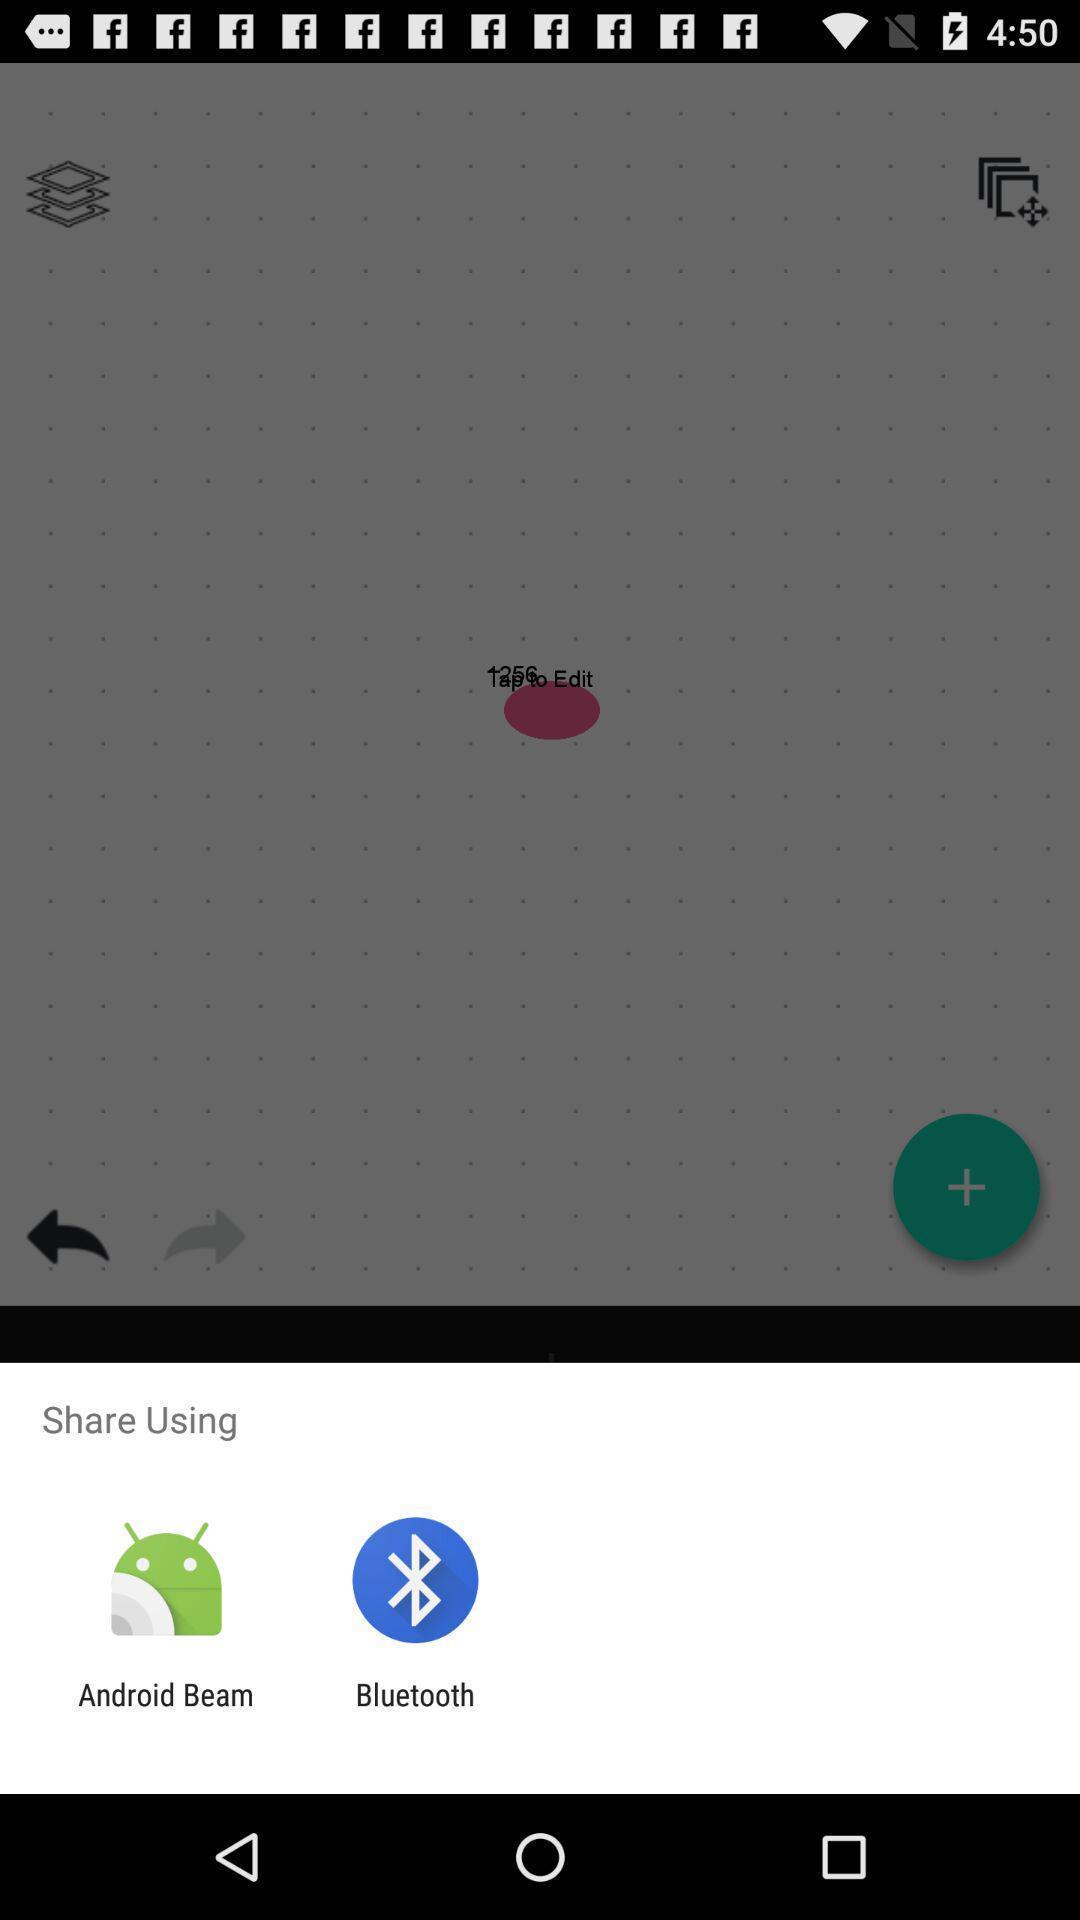What details can you identify in this image? Share page to select through which app to complete action. 